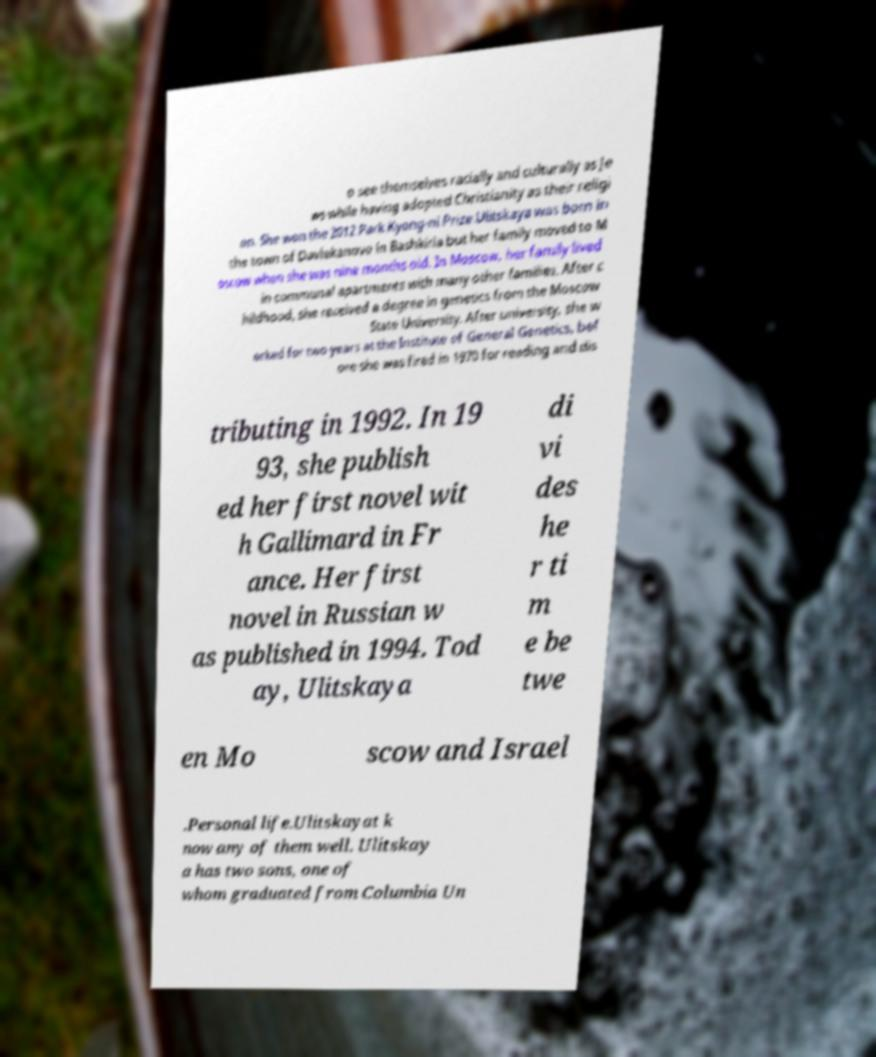I need the written content from this picture converted into text. Can you do that? o see themselves racially and culturally as Je ws while having adopted Christianity as their religi on. She won the 2012 Park Kyong-ni Prize.Ulitskaya was born in the town of Davlekanovo in Bashkiria but her family moved to M oscow when she was nine months old. In Moscow, her family lived in communal apartments with many other families. After c hildhood, she received a degree in genetics from the Moscow State University. After university, she w orked for two years at the Institute of General Genetics, bef ore she was fired in 1970 for reading and dis tributing in 1992. In 19 93, she publish ed her first novel wit h Gallimard in Fr ance. Her first novel in Russian w as published in 1994. Tod ay, Ulitskaya di vi des he r ti m e be twe en Mo scow and Israel .Personal life.Ulitskayat k now any of them well. Ulitskay a has two sons, one of whom graduated from Columbia Un 